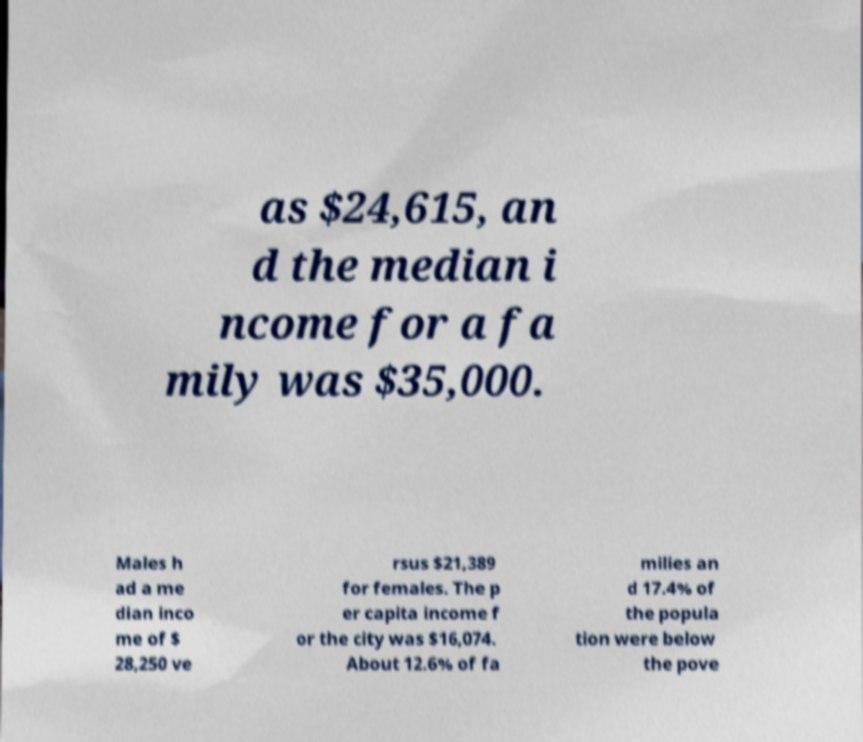Can you accurately transcribe the text from the provided image for me? as $24,615, an d the median i ncome for a fa mily was $35,000. Males h ad a me dian inco me of $ 28,250 ve rsus $21,389 for females. The p er capita income f or the city was $16,074. About 12.6% of fa milies an d 17.4% of the popula tion were below the pove 